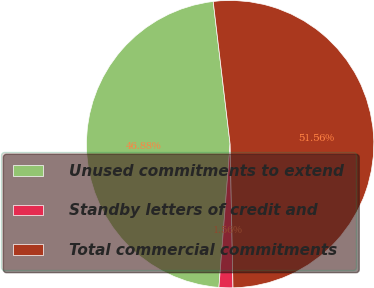<chart> <loc_0><loc_0><loc_500><loc_500><pie_chart><fcel>Unused commitments to extend<fcel>Standby letters of credit and<fcel>Total commercial commitments<nl><fcel>46.88%<fcel>1.56%<fcel>51.56%<nl></chart> 